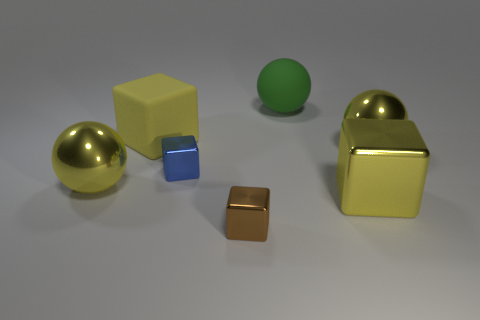Is the number of big balls behind the tiny blue block greater than the number of small brown metallic balls?
Provide a short and direct response. Yes. What is the shape of the matte object that is the same color as the large metal cube?
Provide a succinct answer. Cube. Is there another small block made of the same material as the blue block?
Your response must be concise. Yes. Does the yellow sphere to the left of the yellow rubber block have the same material as the small cube that is behind the tiny brown metallic thing?
Make the answer very short. Yes. Are there an equal number of large yellow things that are to the right of the blue block and big things that are in front of the small brown cube?
Give a very brief answer. No. There is a rubber object that is the same size as the rubber ball; what color is it?
Give a very brief answer. Yellow. Is there a rubber thing that has the same color as the matte cube?
Offer a terse response. No. How many things are either yellow things left of the tiny blue block or purple balls?
Give a very brief answer. 2. What number of other things are there of the same size as the yellow rubber object?
Ensure brevity in your answer.  4. What material is the yellow block in front of the yellow sphere in front of the yellow metal sphere that is on the right side of the rubber ball?
Make the answer very short. Metal. 